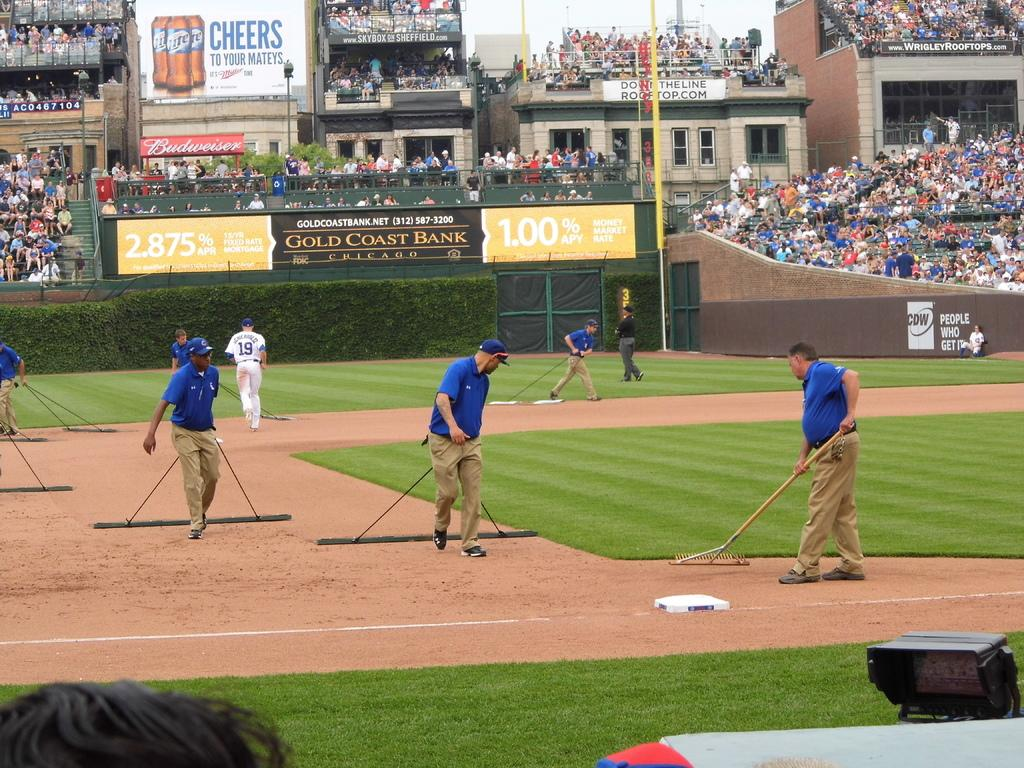Provide a one-sentence caption for the provided image. A CDW ad is visible on the side of a ballpark fence. 